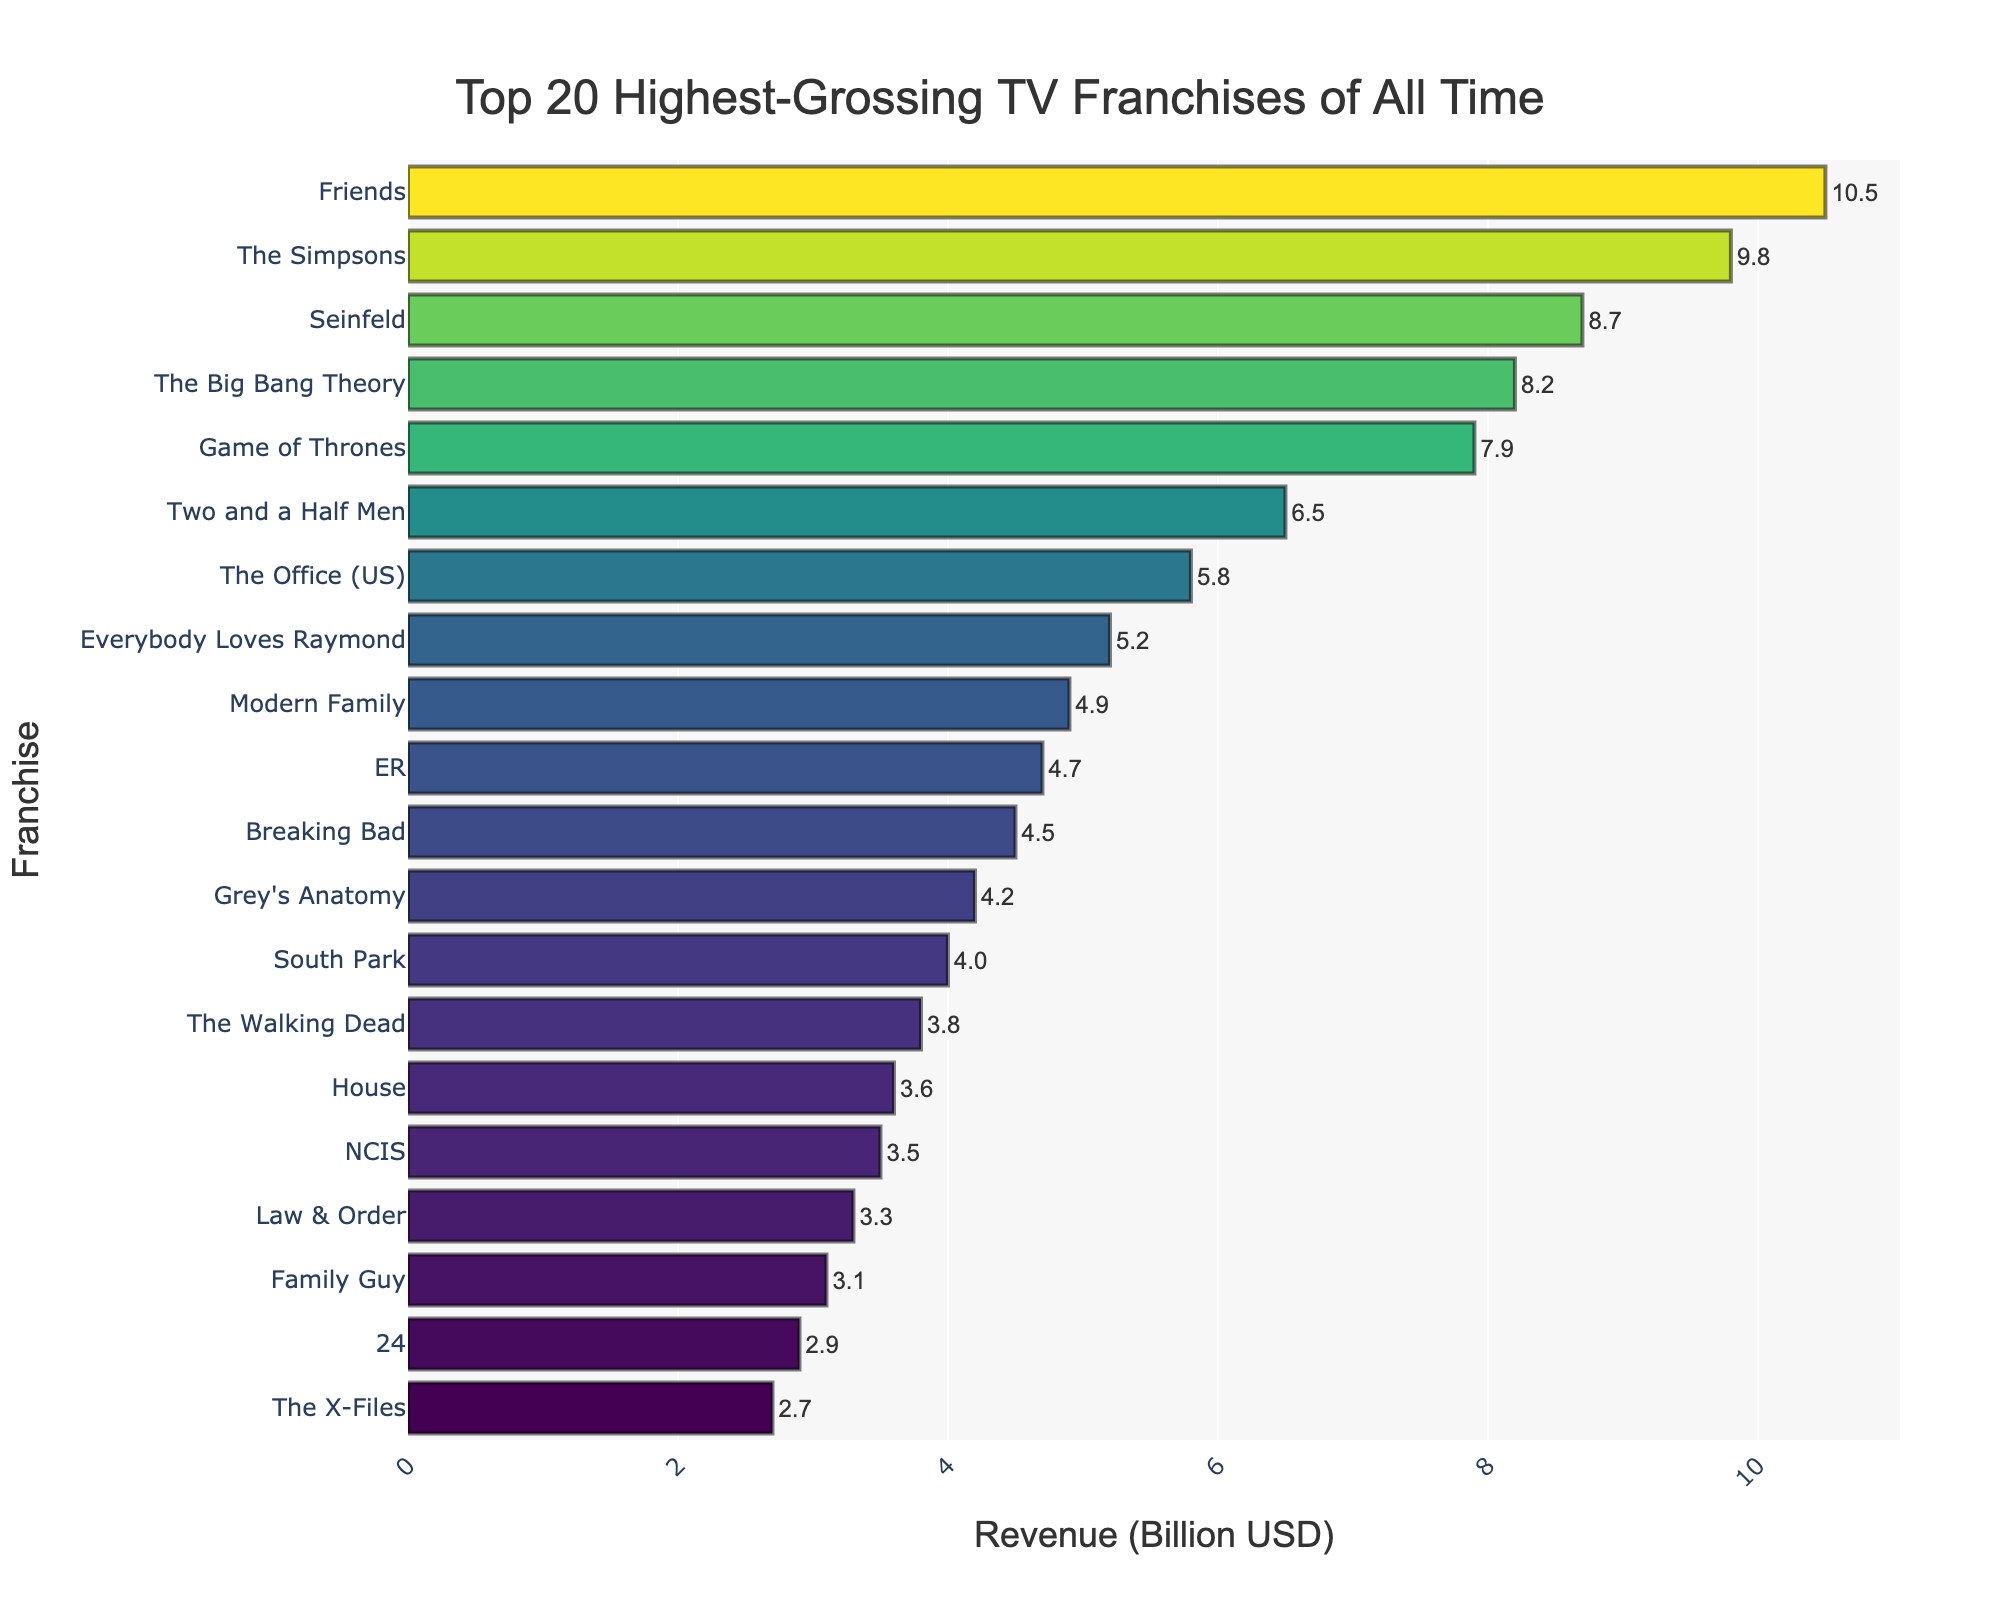Which TV franchise has the highest revenue? The highest revenue is indicated by the longest bar on the bar chart. In this case, "Friends" has the longest bar.
Answer: Friends Which TV franchise has the lowest revenue in the top 10? The lowest revenue in the top 10 is indicated by the shortest bar among the top 10 entries on the bar chart. "The Big Bang Theory" has the shortest bar in the top 10.
Answer: The Big Bang Theory How much more revenue does "Friends" have compared to "The Simpsons"? To find the difference, subtract the revenue of "The Simpsons" (9.8 billion USD) from "Friends" (10.5 billion USD). The calculation is 10.5 - 9.8.
Answer: 0.7 billion USD What is the total revenue of "Seinfeld" and "The Big Bang Theory"? Add the revenue of "Seinfeld" (8.7 billion USD) and "The Big Bang Theory" (8.2 billion USD). The calculation is 8.7 + 8.2.
Answer: 16.9 billion USD Which franchise ranks third in revenue? The third longest bar on the chart represents the third highest revenue. "Seinfeld" has the third longest bar displayed.
Answer: Seinfeld How much revenue separates "The Simpsons" and "Seinfeld"? Subtract the revenue of "Seinfeld" (8.7 billion USD) from "The Simpsons" (9.8 billion USD). The calculation is 9.8 - 8.7.
Answer: 1.1 billion USD What is the total revenue of the top 5 TV franchises combined? Add the revenue of "Friends" (10.5 billion USD), "The Simpsons" (9.8 billion USD), "Seinfeld" (8.7 billion USD), "The Big Bang Theory" (8.2 billion USD), and "Game of Thrones" (7.9 billion USD). The calculation is 10.5 + 9.8 + 8.7 + 8.2 + 7.9.
Answer: 45.1 billion USD Are there any franchises with similar revenue close to each other in ranking? "The Big Bang Theory" and "Game of Thrones" have revenues of 8.2 and 7.9 billion USD respectively, which are close to each other.
Answer: Yes, "The Big Bang Theory" and "Game of Thrones" How many franchises have a revenue greater than 7 billion USD? Count the number of bars longer than the bar representing 7 billion USD. There are 5 franchises: "Friends", "The Simpsons", "Seinfeld", "The Big Bang Theory", and "Game of Thrones".
Answer: Five Which has higher revenue: "Grey's Anatomy" or "South Park"? Compare the length of the bars for "Grey's Anatomy" and "South Park". "Grey's Anatomy" has a longer bar.
Answer: Grey's Anatomy 